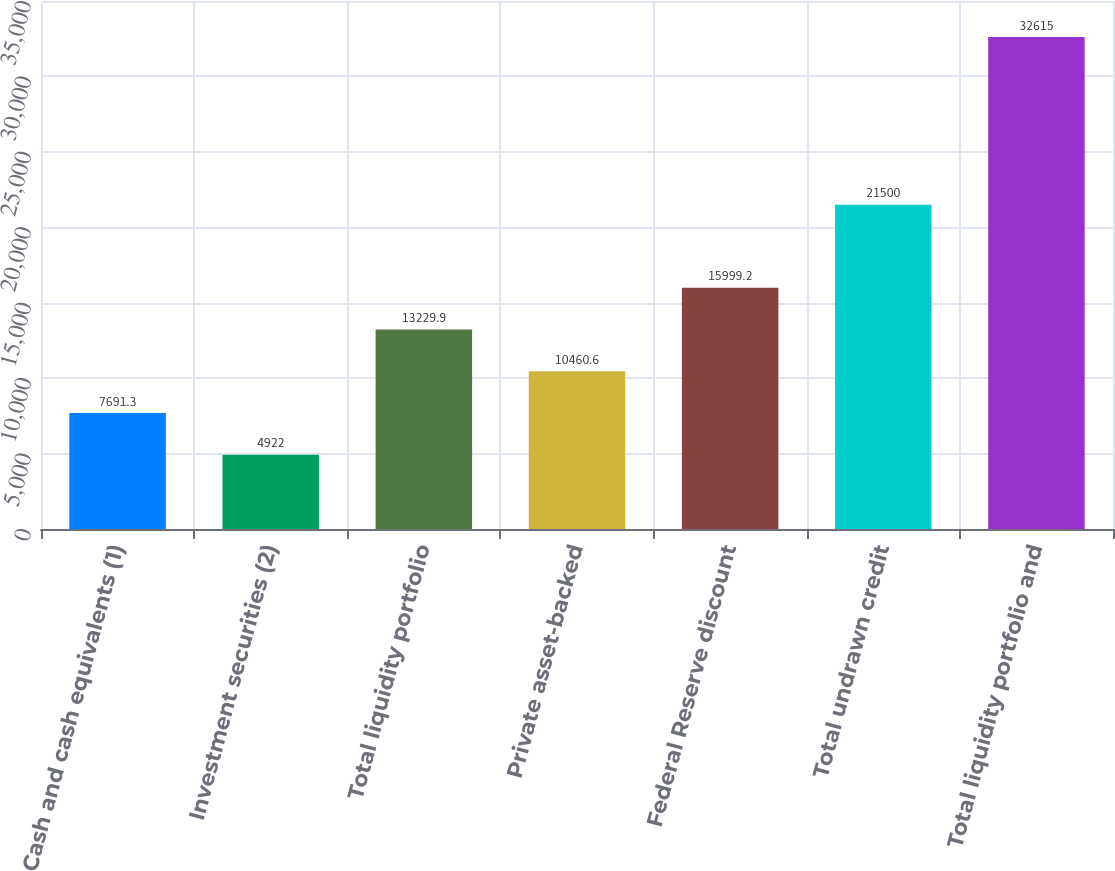Convert chart. <chart><loc_0><loc_0><loc_500><loc_500><bar_chart><fcel>Cash and cash equivalents (1)<fcel>Investment securities (2)<fcel>Total liquidity portfolio<fcel>Private asset-backed<fcel>Federal Reserve discount<fcel>Total undrawn credit<fcel>Total liquidity portfolio and<nl><fcel>7691.3<fcel>4922<fcel>13229.9<fcel>10460.6<fcel>15999.2<fcel>21500<fcel>32615<nl></chart> 